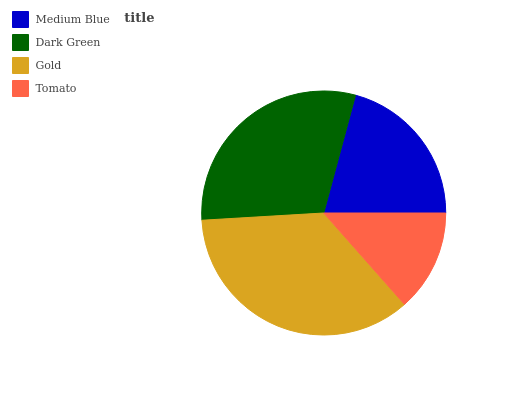Is Tomato the minimum?
Answer yes or no. Yes. Is Gold the maximum?
Answer yes or no. Yes. Is Dark Green the minimum?
Answer yes or no. No. Is Dark Green the maximum?
Answer yes or no. No. Is Dark Green greater than Medium Blue?
Answer yes or no. Yes. Is Medium Blue less than Dark Green?
Answer yes or no. Yes. Is Medium Blue greater than Dark Green?
Answer yes or no. No. Is Dark Green less than Medium Blue?
Answer yes or no. No. Is Dark Green the high median?
Answer yes or no. Yes. Is Medium Blue the low median?
Answer yes or no. Yes. Is Gold the high median?
Answer yes or no. No. Is Tomato the low median?
Answer yes or no. No. 